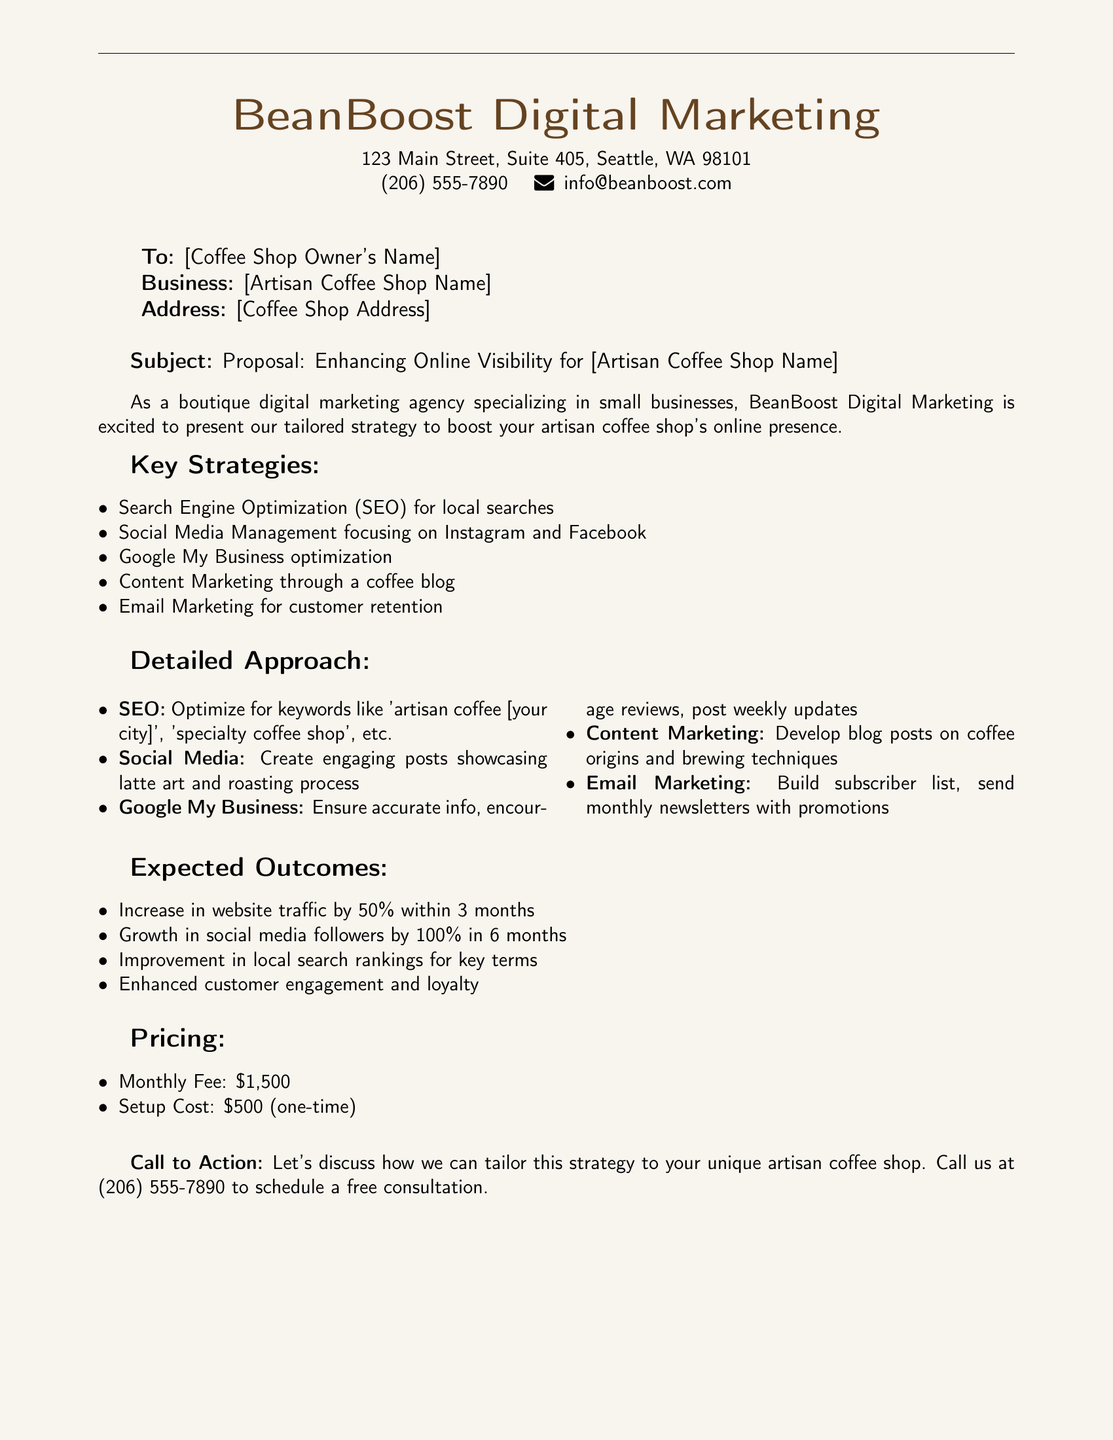What is the monthly fee for the service? The document states the monthly fee as \$1,500.
Answer: \$1,500 What is the one-time setup cost? According to the document, the setup cost is \$500 (one-time).
Answer: \$500 Who is the sender of the proposal? The proposal is from BeanBoost Digital Marketing.
Answer: BeanBoost Digital Marketing What is one of the key strategies mentioned for improving online visibility? One of the strategies listed in the document is Social Media Management.
Answer: Social Media Management What is the expected increase in website traffic within 3 months? The document indicates an expected increase of 50% in website traffic.
Answer: 50% What type of content marketing is suggested for the coffee shop? The document suggests developing a blog on coffee origins and brewing techniques.
Answer: Blog on coffee origins and brewing techniques What platforms are recommended for social media management? The proposal mentions focusing on Instagram and Facebook.
Answer: Instagram and Facebook What is the goal for growth in social media followers within 6 months? The document states the goal is to grow social media followers by 100%.
Answer: 100% How can the coffee shop owner contact the agency for a consultation? The document provides a contact number for scheduling a free consultation at (206) 555-7890.
Answer: (206) 555-7890 